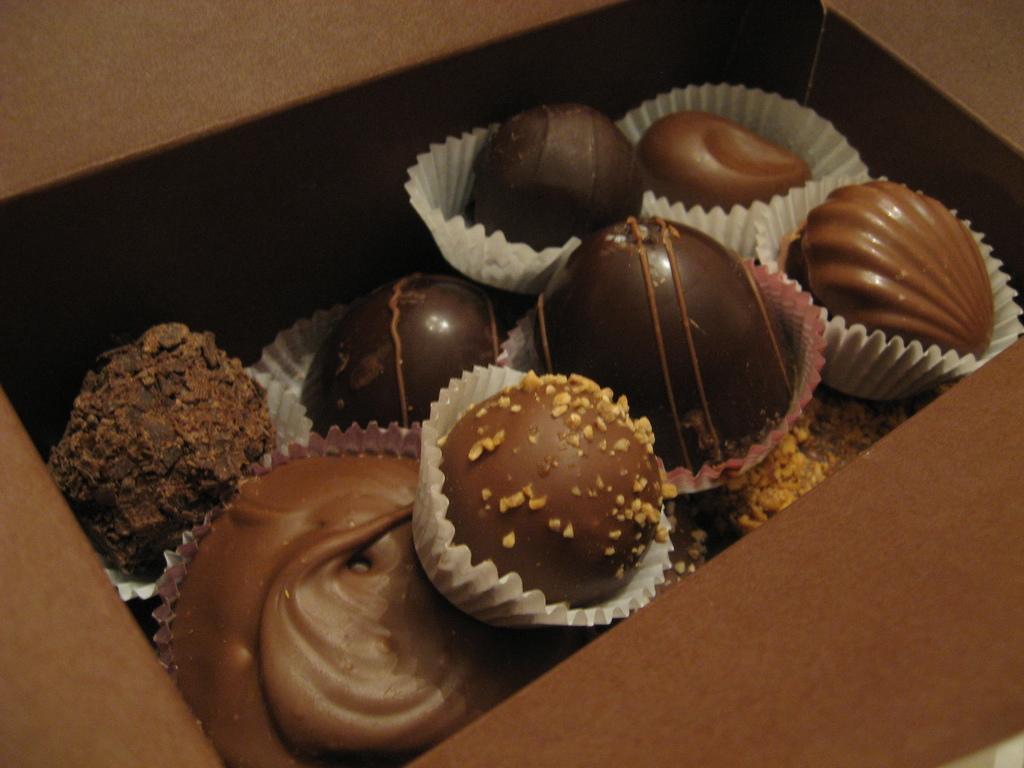Describe this image in one or two sentences. In this image I can see few chocolate cakes in a brown color box. 